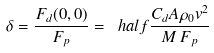<formula> <loc_0><loc_0><loc_500><loc_500>\delta = \frac { F _ { d } ( 0 , 0 ) } { F _ { p } } = \ h a l f \frac { C _ { d } A \rho _ { 0 } v ^ { 2 } } { M \, F _ { p } }</formula> 